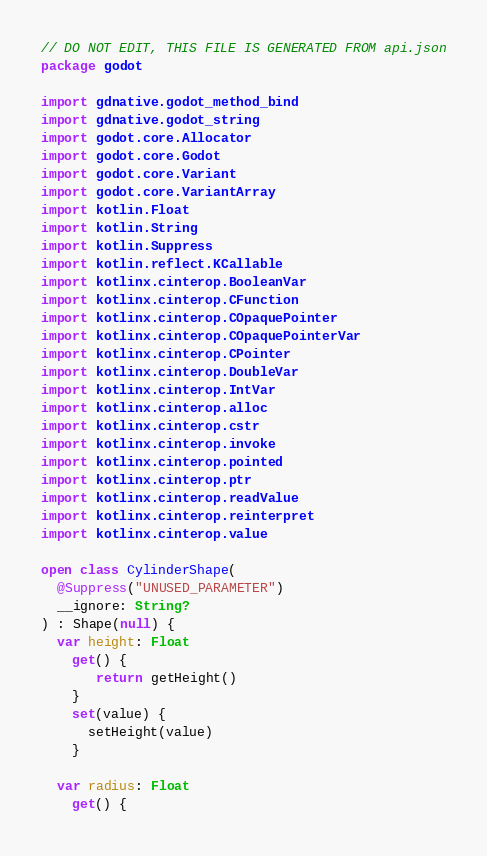Convert code to text. <code><loc_0><loc_0><loc_500><loc_500><_Kotlin_>// DO NOT EDIT, THIS FILE IS GENERATED FROM api.json
package godot

import gdnative.godot_method_bind
import gdnative.godot_string
import godot.core.Allocator
import godot.core.Godot
import godot.core.Variant
import godot.core.VariantArray
import kotlin.Float
import kotlin.String
import kotlin.Suppress
import kotlin.reflect.KCallable
import kotlinx.cinterop.BooleanVar
import kotlinx.cinterop.CFunction
import kotlinx.cinterop.COpaquePointer
import kotlinx.cinterop.COpaquePointerVar
import kotlinx.cinterop.CPointer
import kotlinx.cinterop.DoubleVar
import kotlinx.cinterop.IntVar
import kotlinx.cinterop.alloc
import kotlinx.cinterop.cstr
import kotlinx.cinterop.invoke
import kotlinx.cinterop.pointed
import kotlinx.cinterop.ptr
import kotlinx.cinterop.readValue
import kotlinx.cinterop.reinterpret
import kotlinx.cinterop.value

open class CylinderShape(
  @Suppress("UNUSED_PARAMETER")
  __ignore: String?
) : Shape(null) {
  var height: Float
    get() {
       return getHeight() 
    }
    set(value) {
      setHeight(value)
    }

  var radius: Float
    get() {</code> 